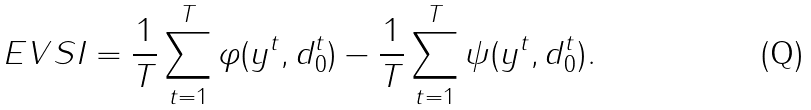<formula> <loc_0><loc_0><loc_500><loc_500>E V S I = \frac { 1 } { T } \sum _ { t = 1 } ^ { T } \varphi ( y ^ { t } , d _ { 0 } ^ { t } ) - \frac { 1 } { T } \sum _ { t = 1 } ^ { T } \psi ( y ^ { t } , d _ { 0 } ^ { t } ) .</formula> 